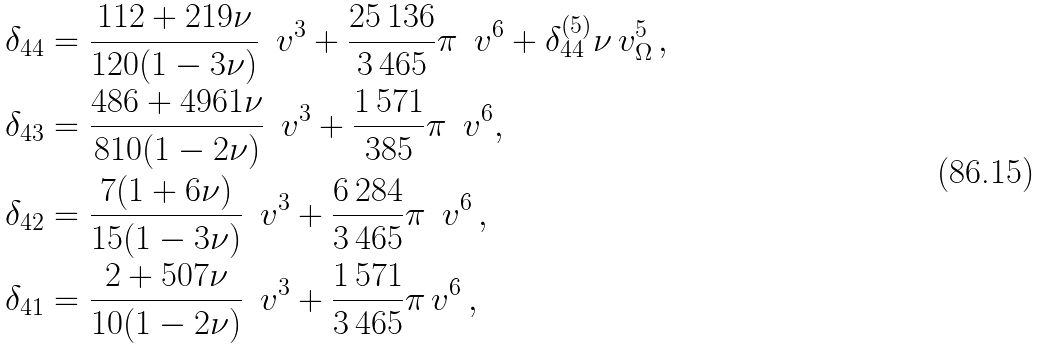Convert formula to latex. <formula><loc_0><loc_0><loc_500><loc_500>\delta _ { 4 4 } & = \frac { 1 1 2 + 2 1 9 \nu } { 1 2 0 ( 1 - 3 \nu ) } \, \ v ^ { 3 } + \frac { 2 5 \, 1 3 6 } { 3 \, 4 6 5 } \pi \, \ v ^ { 6 } + \delta _ { 4 4 } ^ { ( 5 ) } \nu \, v _ { \Omega } ^ { 5 } \, , \\ \delta _ { 4 3 } & = \frac { 4 8 6 + 4 9 6 1 \nu } { 8 1 0 ( 1 - 2 \nu ) } \, \ v ^ { 3 } + \frac { 1 \, 5 7 1 } { 3 8 5 } \pi \, \ v ^ { 6 } , \\ \delta _ { 4 2 } & = \frac { 7 ( 1 + 6 \nu ) } { 1 5 ( 1 - 3 \nu ) } \, \ v ^ { 3 } + \frac { 6 \, 2 8 4 } { 3 \, 4 6 5 } \pi \, \ v ^ { 6 } \, , \\ \delta _ { 4 1 } & = \frac { 2 + 5 0 7 \nu } { 1 0 ( 1 - 2 \nu ) } \, \ v ^ { 3 } + \frac { 1 \, 5 7 1 } { 3 \, 4 6 5 } \pi \, v ^ { 6 } \, ,</formula> 